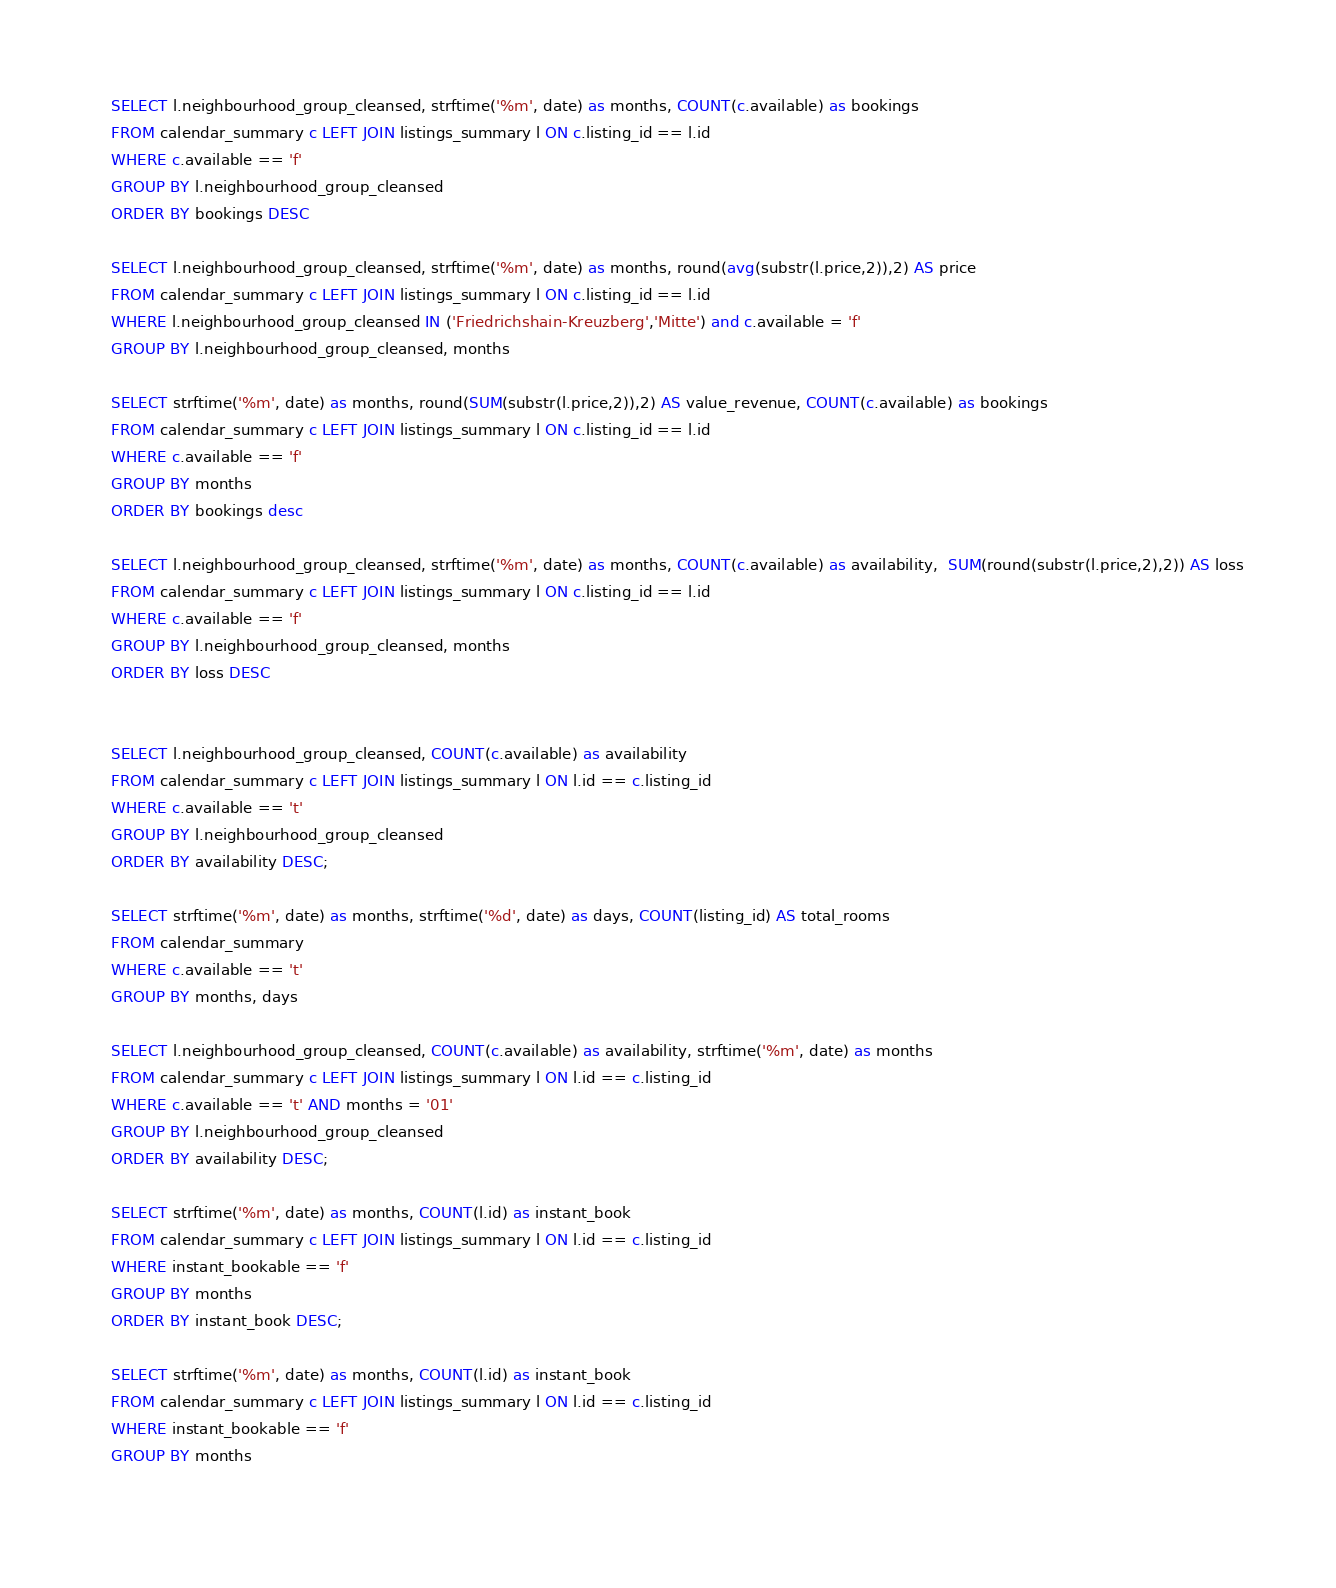<code> <loc_0><loc_0><loc_500><loc_500><_SQL_>    SELECT l.neighbourhood_group_cleansed, strftime('%m', date) as months, COUNT(c.available) as bookings 
    FROM calendar_summary c LEFT JOIN listings_summary l ON c.listing_id == l.id 
    WHERE c.available == 'f' 
    GROUP BY l.neighbourhood_group_cleansed 
    ORDER BY bookings DESC
    
    SELECT l.neighbourhood_group_cleansed, strftime('%m', date) as months, round(avg(substr(l.price,2)),2) AS price
    FROM calendar_summary c LEFT JOIN listings_summary l ON c.listing_id == l.id 
    WHERE l.neighbourhood_group_cleansed IN ('Friedrichshain-Kreuzberg','Mitte') and c.available = 'f'
    GROUP BY l.neighbourhood_group_cleansed, months
    
    SELECT strftime('%m', date) as months, round(SUM(substr(l.price,2)),2) AS value_revenue, COUNT(c.available) as bookings
    FROM calendar_summary c LEFT JOIN listings_summary l ON c.listing_id == l.id 
    WHERE c.available == 'f' 
    GROUP BY months
    ORDER BY bookings desc
    
    SELECT l.neighbourhood_group_cleansed, strftime('%m', date) as months, COUNT(c.available) as availability,  SUM(round(substr(l.price,2),2)) AS loss
    FROM calendar_summary c LEFT JOIN listings_summary l ON c.listing_id == l.id 
    WHERE c.available == 'f' 
    GROUP BY l.neighbourhood_group_cleansed, months
    ORDER BY loss DESC
    
    
    SELECT l.neighbourhood_group_cleansed, COUNT(c.available) as availability
    FROM calendar_summary c LEFT JOIN listings_summary l ON l.id == c.listing_id 
    WHERE c.available == 't' 
    GROUP BY l.neighbourhood_group_cleansed 
    ORDER BY availability DESC;
    
    SELECT strftime('%m', date) as months, strftime('%d', date) as days, COUNT(listing_id) AS total_rooms
    FROM calendar_summary 
    WHERE c.available == 't'
    GROUP BY months, days
    
    SELECT l.neighbourhood_group_cleansed, COUNT(c.available) as availability, strftime('%m', date) as months
    FROM calendar_summary c LEFT JOIN listings_summary l ON l.id == c.listing_id 
    WHERE c.available == 't' AND months = '01'
    GROUP BY l.neighbourhood_group_cleansed 
    ORDER BY availability DESC;
    
    SELECT strftime('%m', date) as months, COUNT(l.id) as instant_book
    FROM calendar_summary c LEFT JOIN listings_summary l ON l.id == c.listing_id 
    WHERE instant_bookable == 'f'
    GROUP BY months 
    ORDER BY instant_book DESC;
    
    SELECT strftime('%m', date) as months, COUNT(l.id) as instant_book
    FROM calendar_summary c LEFT JOIN listings_summary l ON l.id == c.listing_id 
    WHERE instant_bookable == 'f'
    GROUP BY months
    </code> 